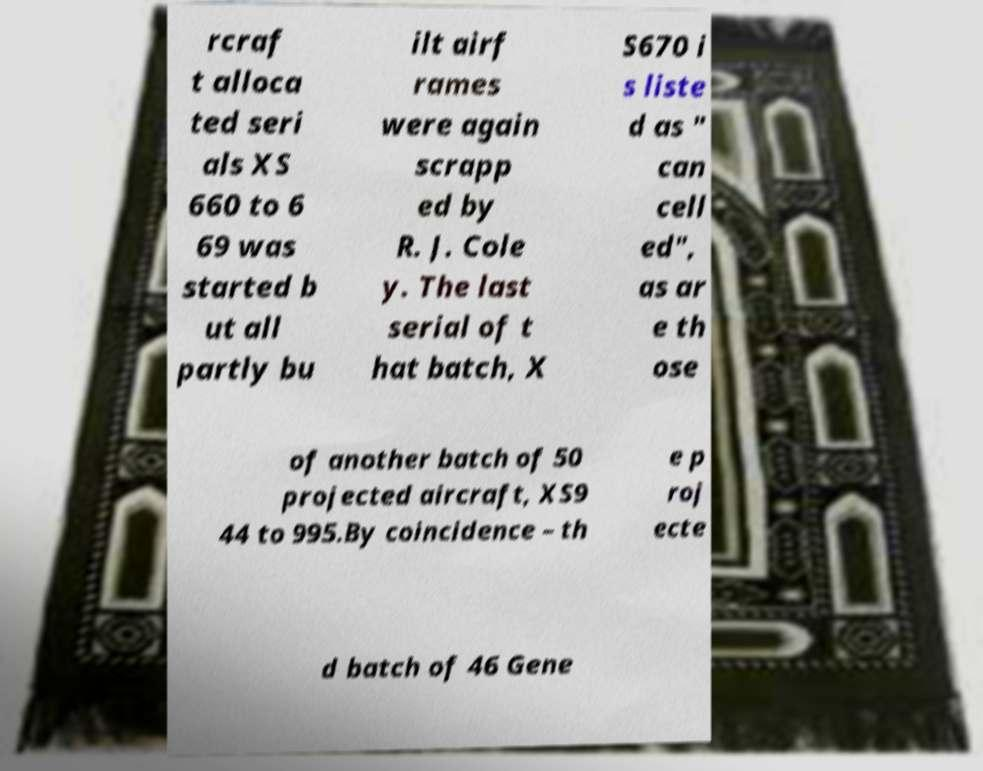For documentation purposes, I need the text within this image transcribed. Could you provide that? rcraf t alloca ted seri als XS 660 to 6 69 was started b ut all partly bu ilt airf rames were again scrapp ed by R. J. Cole y. The last serial of t hat batch, X S670 i s liste d as " can cell ed", as ar e th ose of another batch of 50 projected aircraft, XS9 44 to 995.By coincidence – th e p roj ecte d batch of 46 Gene 